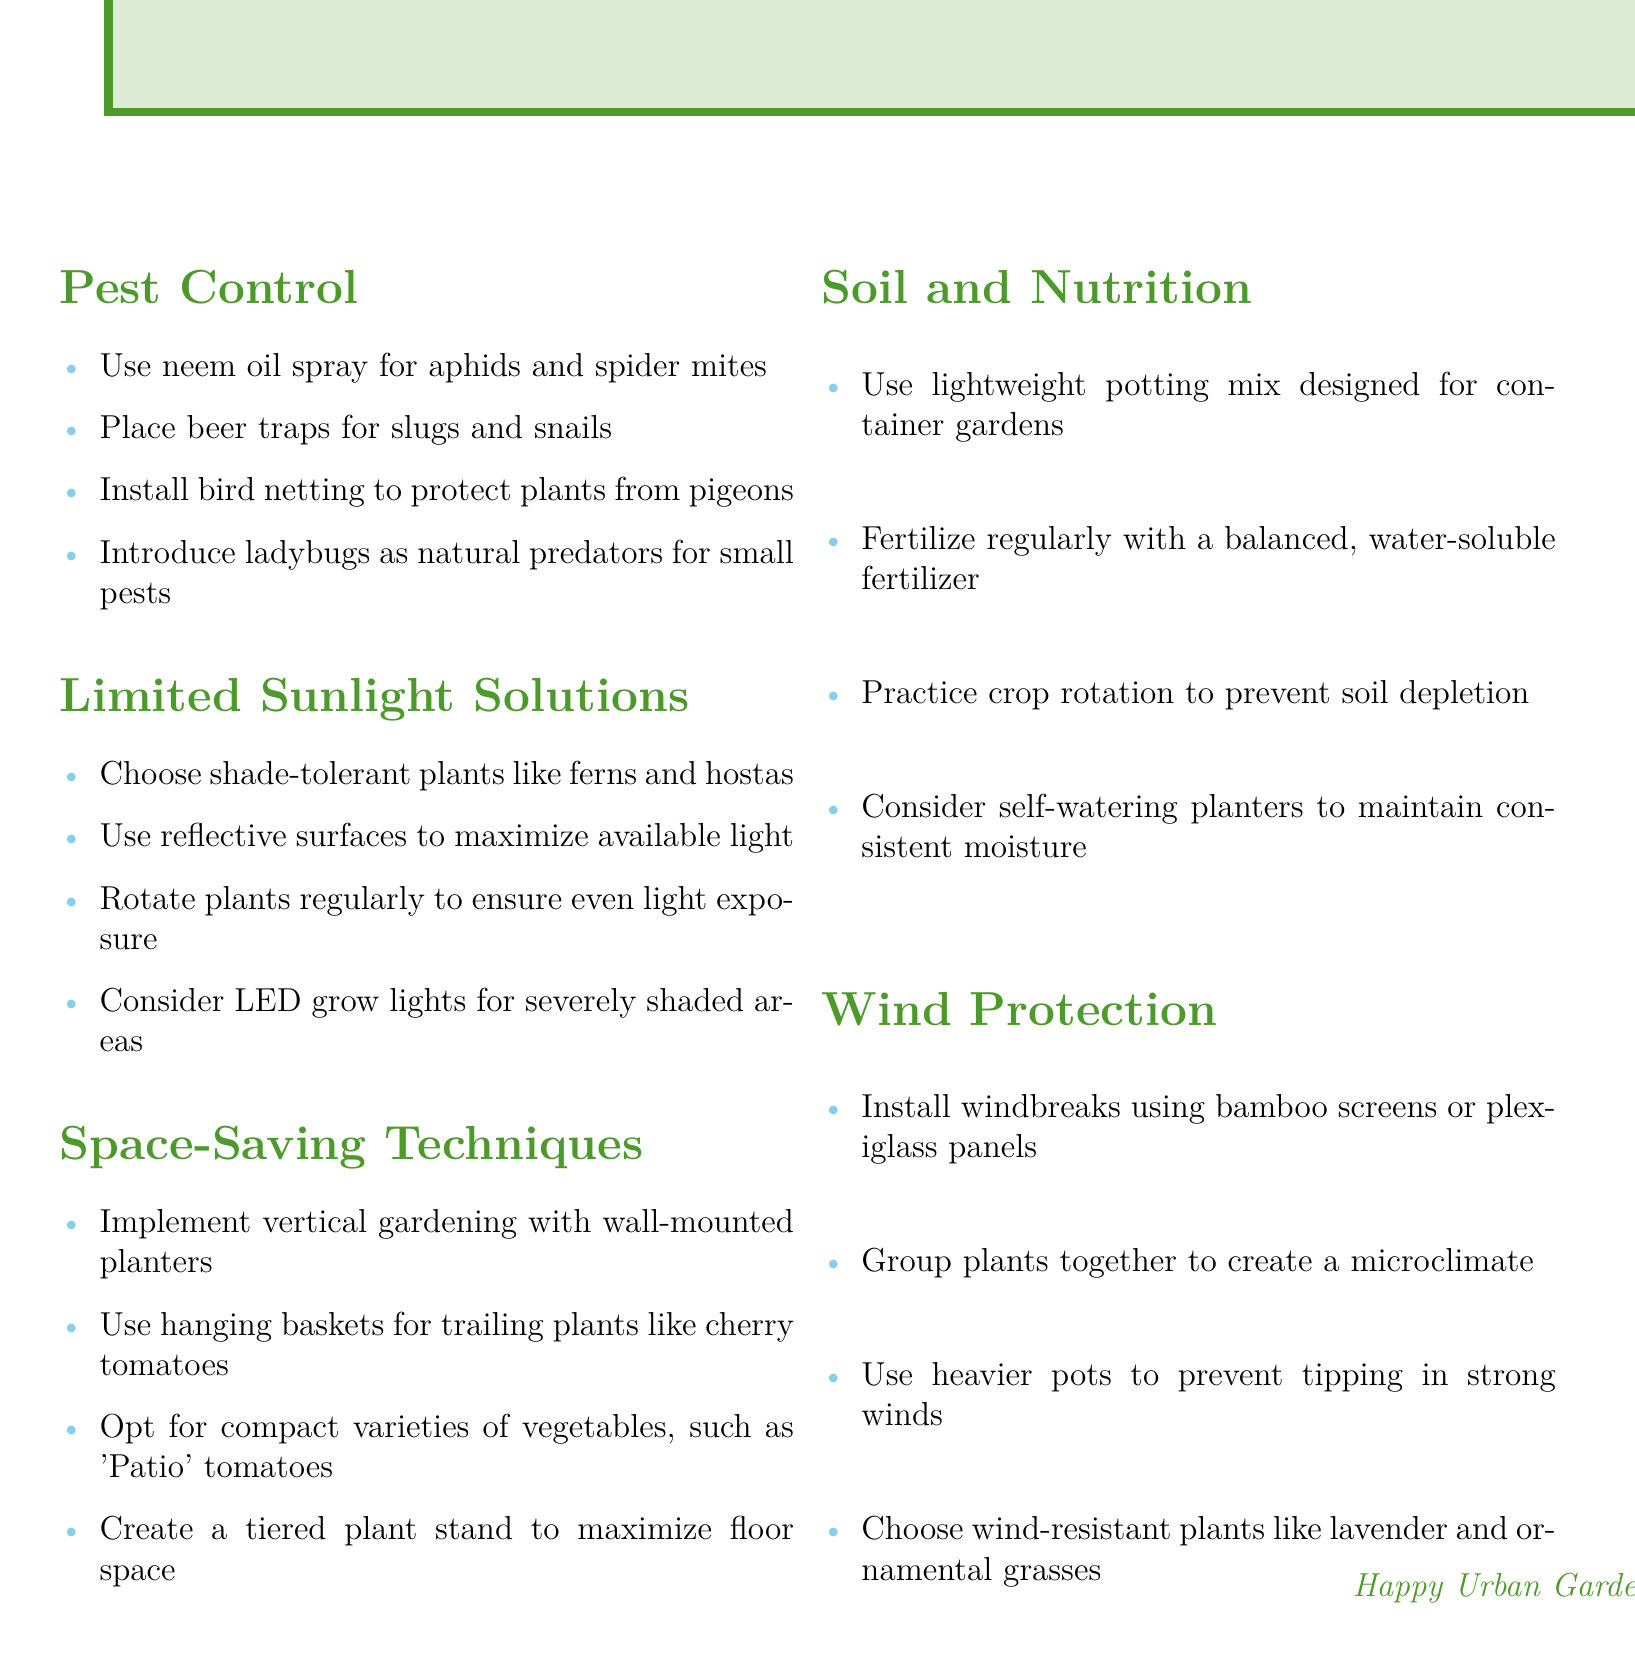What should you use for aphids and spider mites? The document states to use neem oil spray for aphids and spider mites under the Pest Control section.
Answer: neem oil spray What type of plants should you choose for limited sunlight? The document recommends shade-tolerant plants like ferns and hostas for areas with limited sunlight.
Answer: ferns and hostas What technique can maximize floor space? The document suggests creating a tiered plant stand to maximize floor space in the Space-Saving Techniques section.
Answer: tiered plant stand Which plants are mentioned as wind-resistant? The document lists lavender and ornamental grasses as wind-resistant plants in the Wind Protection section.
Answer: lavender and ornamental grasses What is recommended for slug and snail control? According to the Pest Control section, placing beer traps is recommended for slugs and snails.
Answer: beer traps What can be used to protect plants from pigeons? The document mentions installing bird netting to protect plants from pigeons in the Pest Control section.
Answer: bird netting What lighting option is suggested for severely shaded areas? The document advises considering LED grow lights for severely shaded areas under the Limited Sunlight Solutions section.
Answer: LED grow lights How often should you fertilize your balcony garden? The document suggests fertilizing regularly with a balanced, water-soluble fertilizer in the Soil and Nutrition section.
Answer: regularly What should be used for consistent moisture in pots? The document recommends considering self-watering planters to maintain consistent moisture in the Soil and Nutrition section.
Answer: self-watering planters 